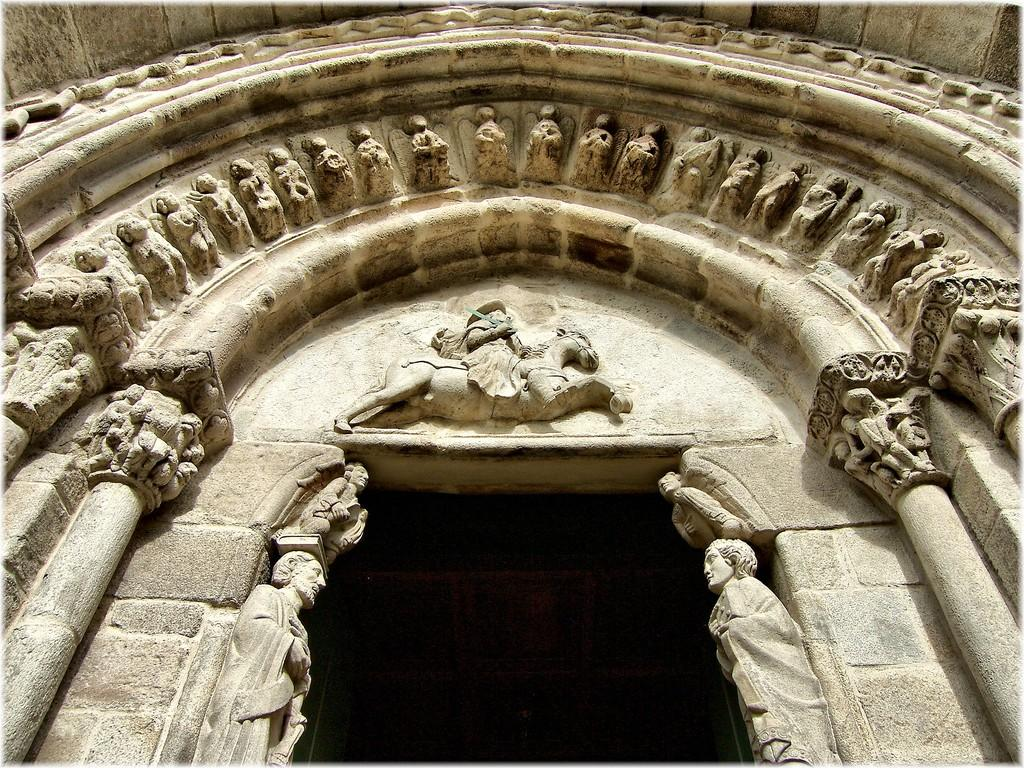What architectural feature can be seen on the building in the image? There is an arch on the building in the image. What decorative elements are present on the wall of the building? There are many sculptures on the wall of the building. What structural elements support the building in the image? There are pillars in the image. Where are the ducks playing in the image? There are no ducks present in the image. What type of grass is growing on the roof of the building in the image? There is no grass visible on the building in the image. 